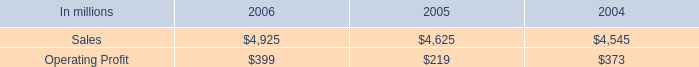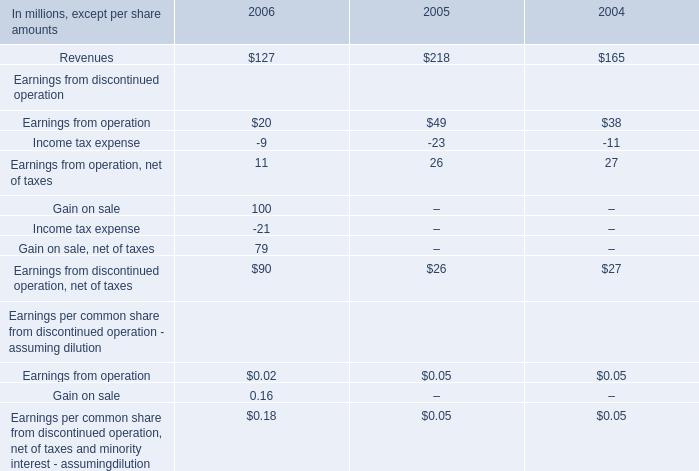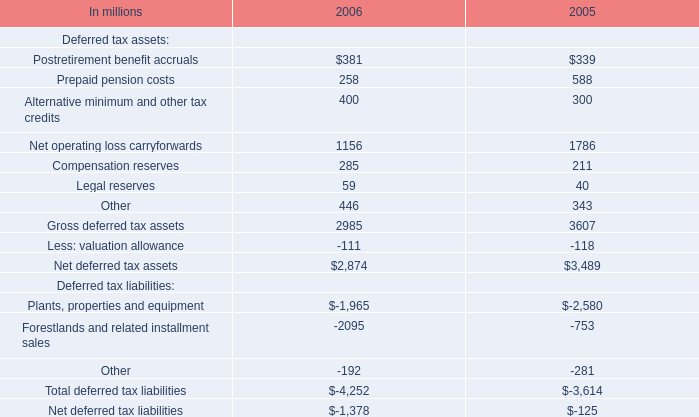what percentage of 2005 industrial packaging sales are containerboard sales? 
Computations: (895 / 4625)
Answer: 0.19351. 